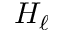<formula> <loc_0><loc_0><loc_500><loc_500>H _ { \ell }</formula> 